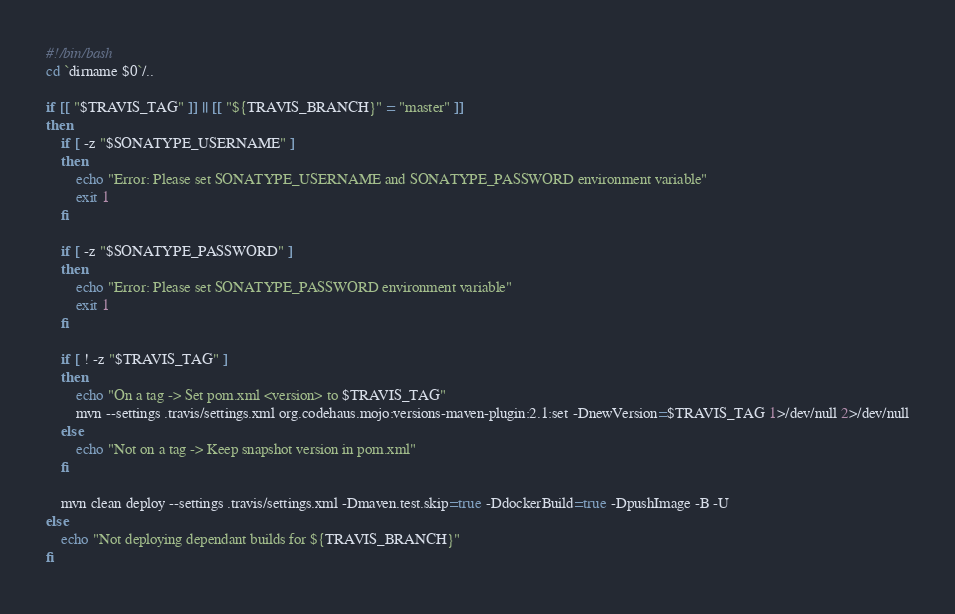<code> <loc_0><loc_0><loc_500><loc_500><_Bash_>#!/bin/bash
cd `dirname $0`/..

if [[ "$TRAVIS_TAG" ]] || [[ "${TRAVIS_BRANCH}" = "master" ]]
then
    if [ -z "$SONATYPE_USERNAME" ]
    then
        echo "Error: Please set SONATYPE_USERNAME and SONATYPE_PASSWORD environment variable"
        exit 1
    fi

    if [ -z "$SONATYPE_PASSWORD" ]
    then
        echo "Error: Please set SONATYPE_PASSWORD environment variable"
        exit 1
    fi

    if [ ! -z "$TRAVIS_TAG" ]
    then
        echo "On a tag -> Set pom.xml <version> to $TRAVIS_TAG"
        mvn --settings .travis/settings.xml org.codehaus.mojo:versions-maven-plugin:2.1:set -DnewVersion=$TRAVIS_TAG 1>/dev/null 2>/dev/null
    else
        echo "Not on a tag -> Keep snapshot version in pom.xml"
    fi

    mvn clean deploy --settings .travis/settings.xml -Dmaven.test.skip=true -DdockerBuild=true -DpushImage -B -U
else
    echo "Not deploying dependant builds for ${TRAVIS_BRANCH}"
fi</code> 